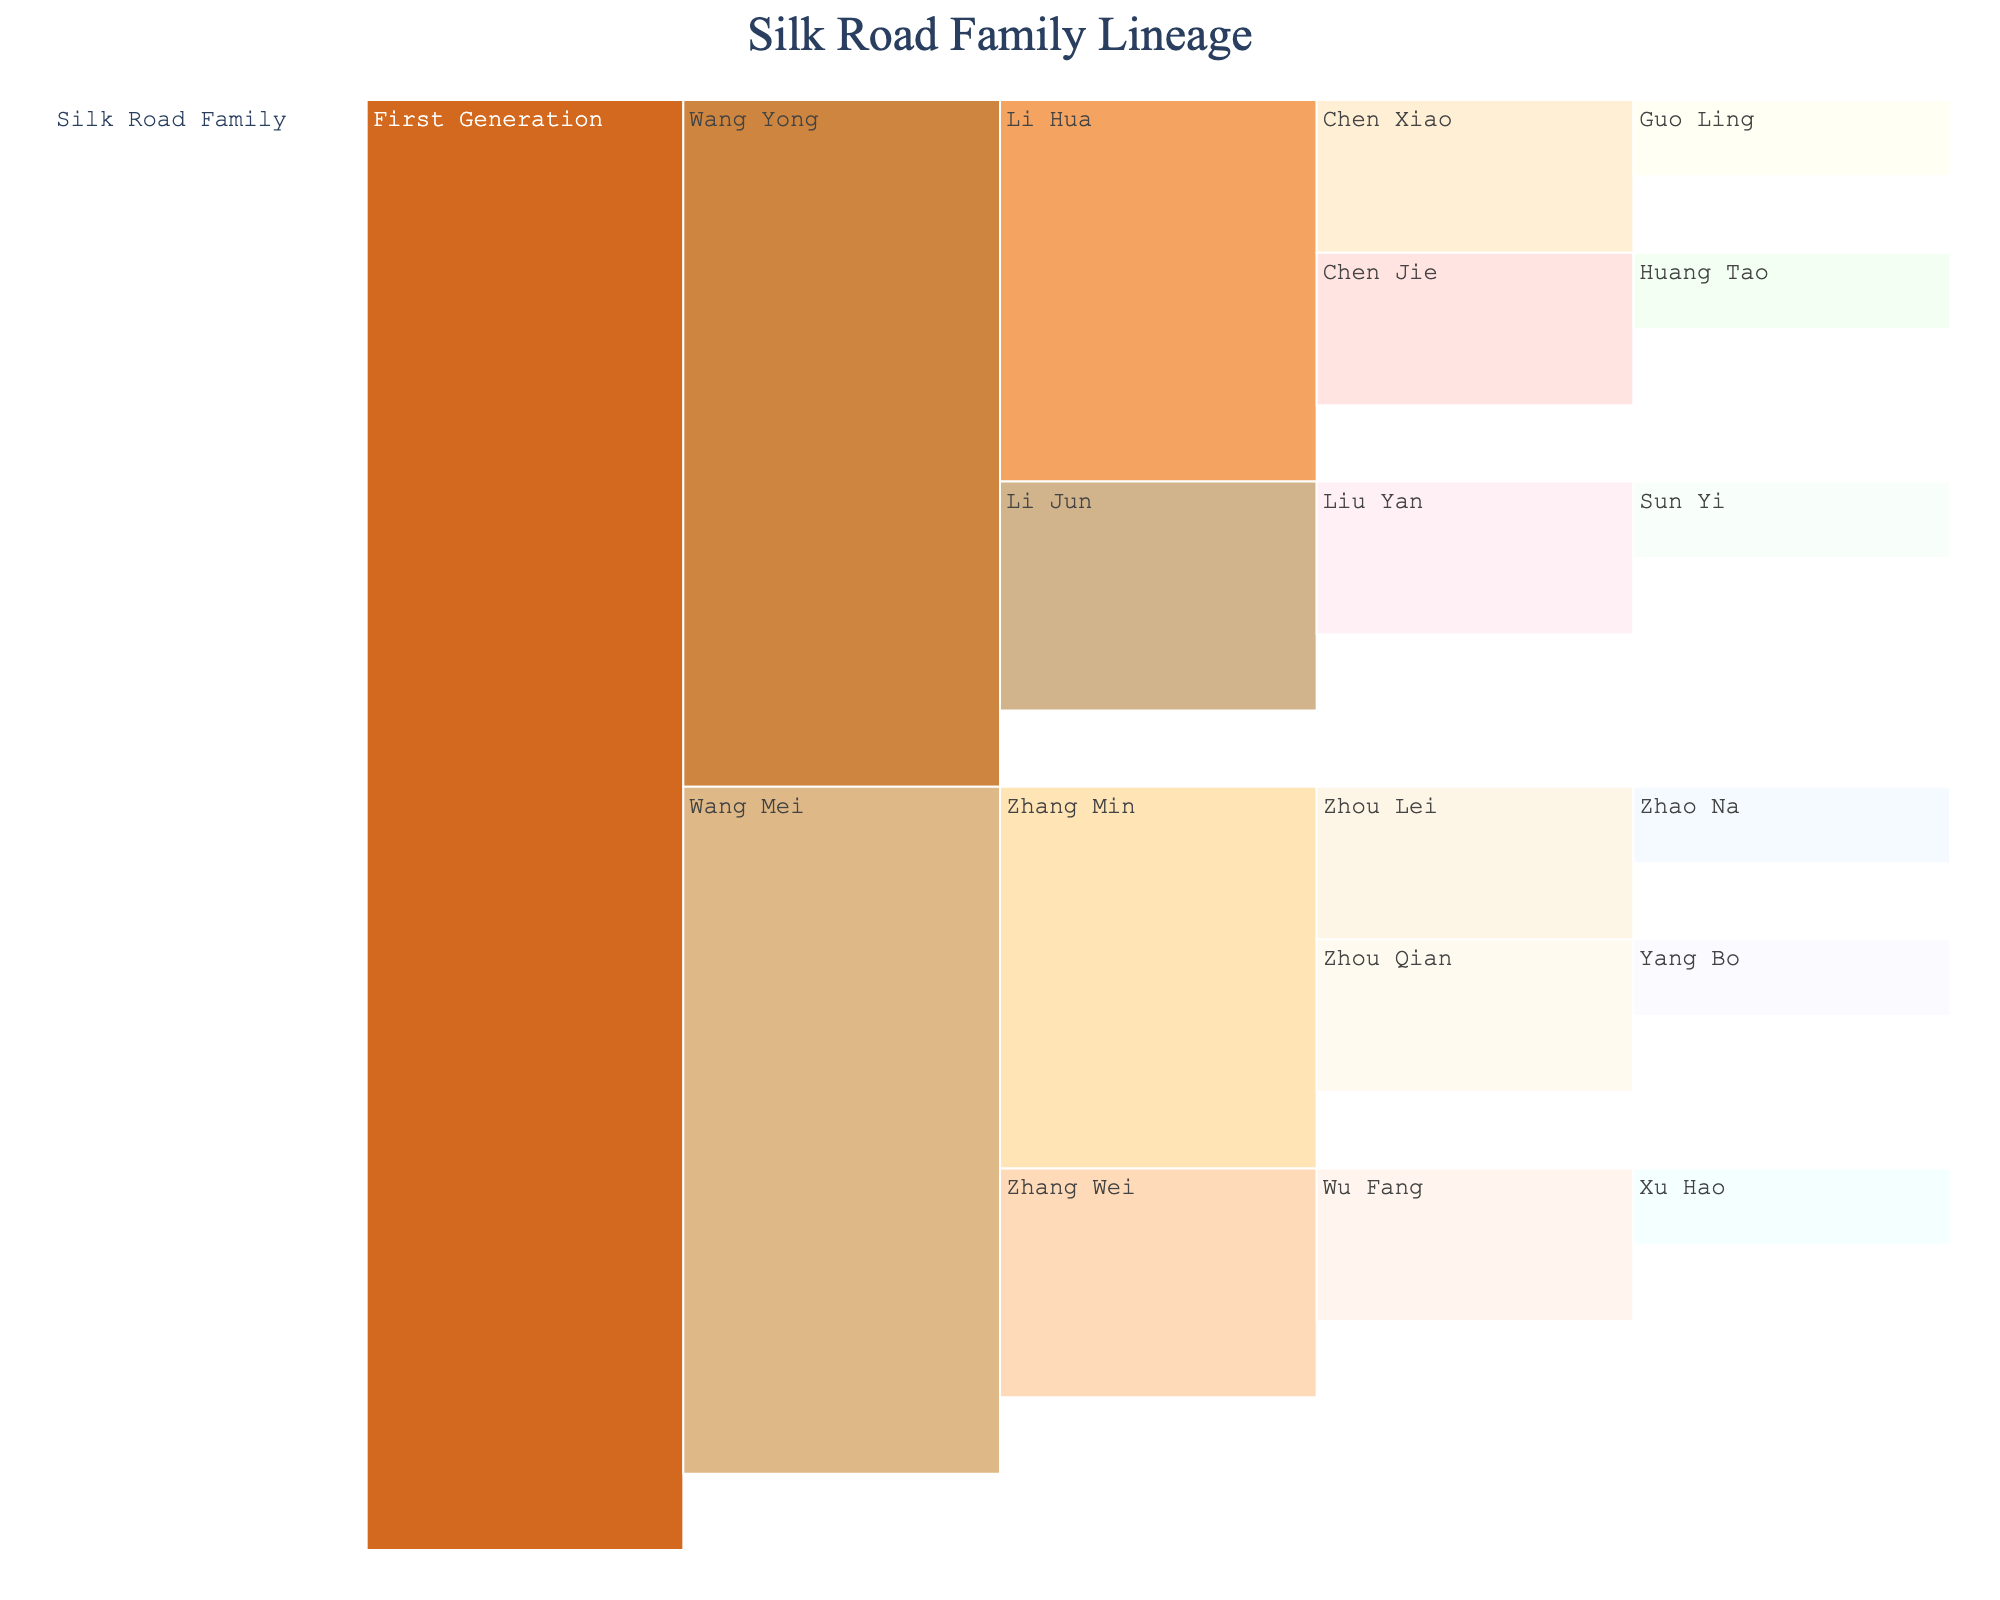What's the title of the chart? The chart's title is usually displayed prominently at the top. In this case, it should read "Silk Road Family Lineage" based on the information provided.
Answer: Silk Road Family Lineage How many generations are represented in the chart? By looking at the layers in the chart, one can count the levels from the root to the leaf nodes. There are five generations represented: Silk Road Family, First Generation, Second Generation (e.g., Wang Yong), Third Generation (e.g., Li Hua), and Fourth Generation (e.g., Chen Xiao).
Answer: 5 Who are the children of Wang Mei? By identifying Wang Mei in the chart and looking at the next level, the children directly connected to Wang Mei are Zhang Wei and Zhang Min.
Answer: Zhang Wei and Zhang Min What color is used for the First Generation? The color map provided assigns colors to each category. For the First Generation, the color '#D2691E' is used.
Answer: A shade of orange (referenced as '#D2691E') Compare the number of children of Li Hua and Zhang Min. Who has more children, and by how many? Li Hua has Chen Xiao and Chen Jie, while Zhang Min has Zhou Lei and Zhou Qian. Both have two children each.
Answer: Both have the same, 2 children What is the relationship between Chen Jie and Huang Tao? By following the hierarchy, Chen Jie is directly above Huang Tao, indicating Chen Jie is Huang Tao’s parent.
Answer: Parent-Child How many branches stem from the First Generation? By looking at the first layer under the First Generation, there are two branches: Wang Yong and Wang Mei.
Answer: 2 branches Which individual has the most descendants listed in this chart? By examining each individual and counting their direct and indirect descendants, Wang Mei has a total of 5 (including all branching levels: Zhang Wei, Zhang Min, Wu Fang, Zhou Lei, and Zhou Qian).
Answer: Wang Mei How are Liu Yan and Sun Yi related in the family hierarchy? Following the hierarchy, Liu Yan is directly above Sun Yi, making Liu Yan the parent of Sun Yi.
Answer: Parent-Child What is common between the descendants of Li Hua and Zhang Min? Both Li Hua and Zhang Min have descendants named using two characters each, following cultural naming practices. Also, they each have children who further branch out.
Answer: Naming and family structure 